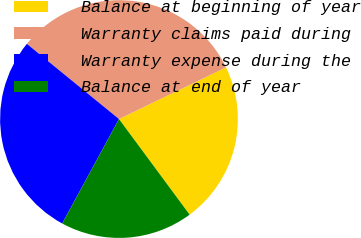Convert chart. <chart><loc_0><loc_0><loc_500><loc_500><pie_chart><fcel>Balance at beginning of year<fcel>Warranty claims paid during<fcel>Warranty expense during the<fcel>Balance at end of year<nl><fcel>22.03%<fcel>31.95%<fcel>27.97%<fcel>18.05%<nl></chart> 